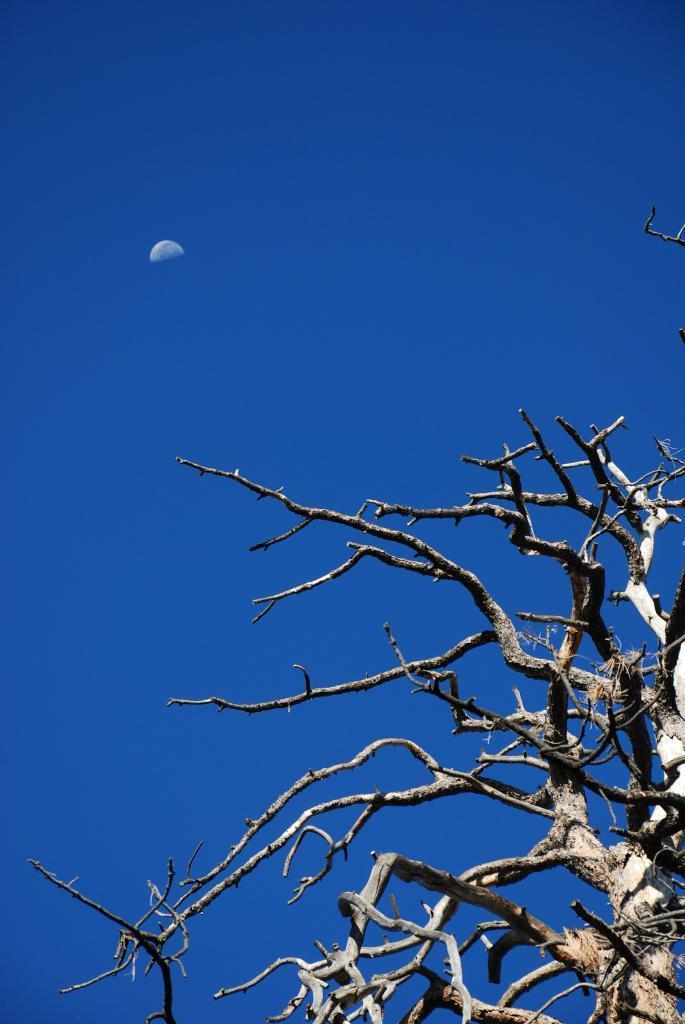Please provide a concise description of this image. In this image at the bottom we can see a bare tree. In the background there is a moon in the sky. 